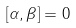Convert formula to latex. <formula><loc_0><loc_0><loc_500><loc_500>\left [ \alpha , \beta \right ] = 0</formula> 